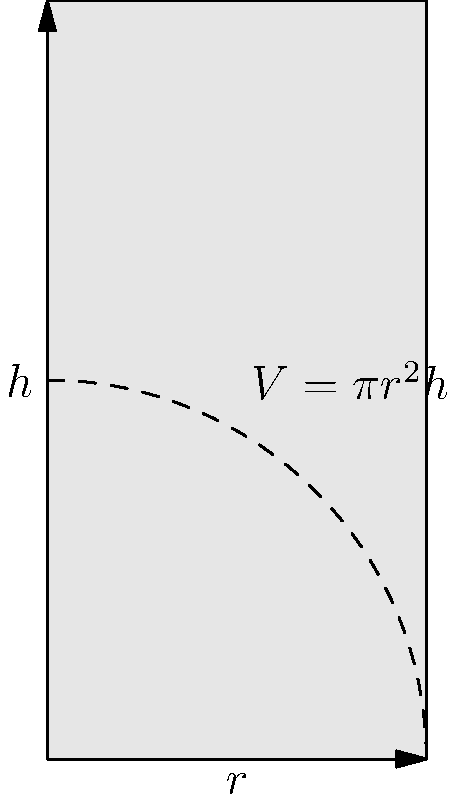As a coffee bean retailer, you want to design a cylindrical container to store your premium coffee. The container needs to have a surface area of 300 cm². What dimensions (radius and height) should the container have to maximize its volume? Round your answer to the nearest centimeter. Let's approach this step-by-step:

1) For a cylinder, we have:
   Surface Area: $SA = 2\pi r^2 + 2\pi rh = 300$
   Volume: $V = \pi r^2 h$

2) From the surface area equation:
   $2\pi r^2 + 2\pi rh = 300$
   $\pi r(r + h) = 150$
   $r + h = \frac{150}{\pi r}$

3) Solve for h:
   $h = \frac{150}{\pi r} - r$

4) Substitute this into the volume equation:
   $V = \pi r^2 (\frac{150}{\pi r} - r) = 150r - \pi r^3$

5) To find the maximum volume, differentiate V with respect to r and set to zero:
   $\frac{dV}{dr} = 150 - 3\pi r^2 = 0$

6) Solve this equation:
   $150 = 3\pi r^2$
   $r^2 = \frac{50}{\pi}$
   $r = \sqrt{\frac{50}{\pi}} \approx 3.99$ cm

7) Round to the nearest cm: $r = 4$ cm

8) Calculate h:
   $h = \frac{150}{\pi r} - r = \frac{150}{\pi(4)} - 4 \approx 7.96$ cm

9) Round to the nearest cm: $h = 8$ cm

Therefore, to maximize the volume, the container should have a radius of 4 cm and a height of 8 cm.
Answer: $r = 4$ cm, $h = 8$ cm 